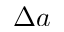Convert formula to latex. <formula><loc_0><loc_0><loc_500><loc_500>\Delta a</formula> 